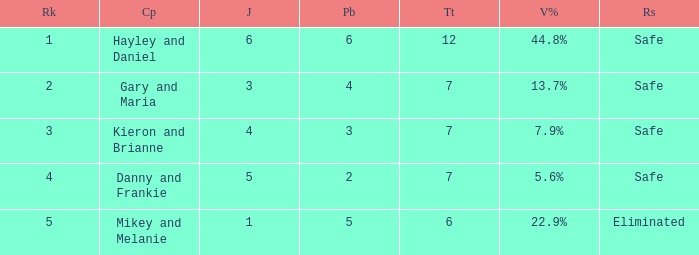How many public is there for the couple that got eliminated? 5.0. 